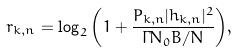Convert formula to latex. <formula><loc_0><loc_0><loc_500><loc_500>r _ { k , n } = \log _ { 2 } { \left ( 1 + \frac { P _ { k , n } | h _ { k , n } | ^ { 2 } } { \Gamma N _ { 0 } B / N } \right ) } ,</formula> 